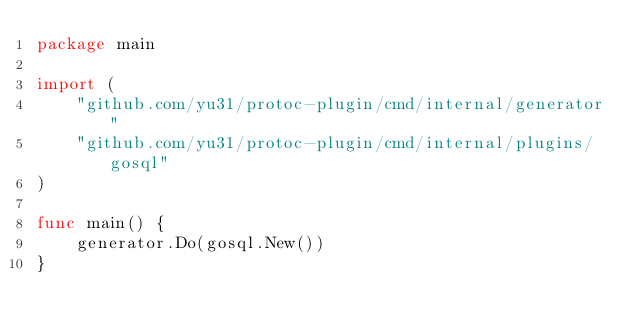Convert code to text. <code><loc_0><loc_0><loc_500><loc_500><_Go_>package main

import (
	"github.com/yu31/protoc-plugin/cmd/internal/generator"
	"github.com/yu31/protoc-plugin/cmd/internal/plugins/gosql"
)

func main() {
	generator.Do(gosql.New())
}
</code> 